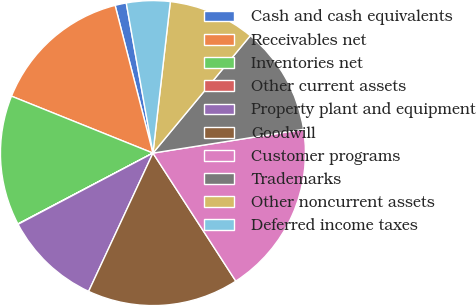<chart> <loc_0><loc_0><loc_500><loc_500><pie_chart><fcel>Cash and cash equivalents<fcel>Receivables net<fcel>Inventories net<fcel>Other current assets<fcel>Property plant and equipment<fcel>Goodwill<fcel>Customer programs<fcel>Trademarks<fcel>Other noncurrent assets<fcel>Deferred income taxes<nl><fcel>1.19%<fcel>14.92%<fcel>13.78%<fcel>0.04%<fcel>10.34%<fcel>16.07%<fcel>18.35%<fcel>11.49%<fcel>9.2%<fcel>4.62%<nl></chart> 